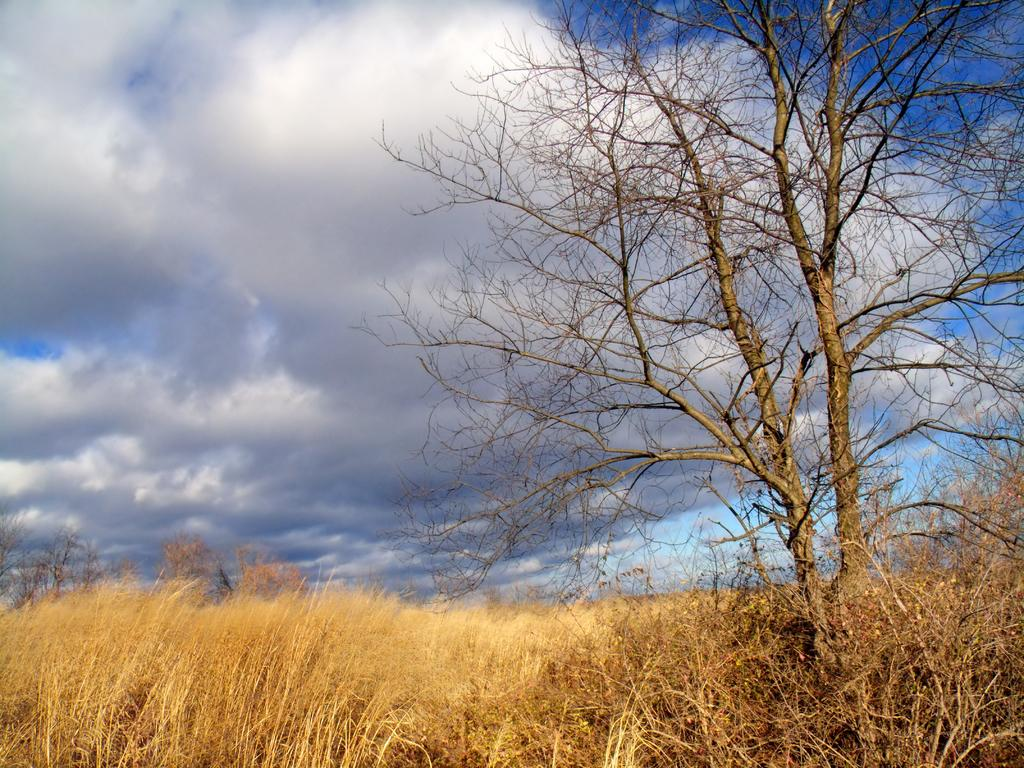What type of vegetation can be seen at the bottom of the image? There are dry trees, dry plants, and dry grass on the ground at the bottom of the image. What is the color of the sky in the background of the image? The sky in the background of the image is blue. What can be seen in the sky besides the blue color? There are clouds in the blue sky in the background of the image. How many rings are visible on the dry trees in the image? There are no rings visible on the dry trees in the image, as rings are typically associated with tree growth and not visible on the surface of the tree. 